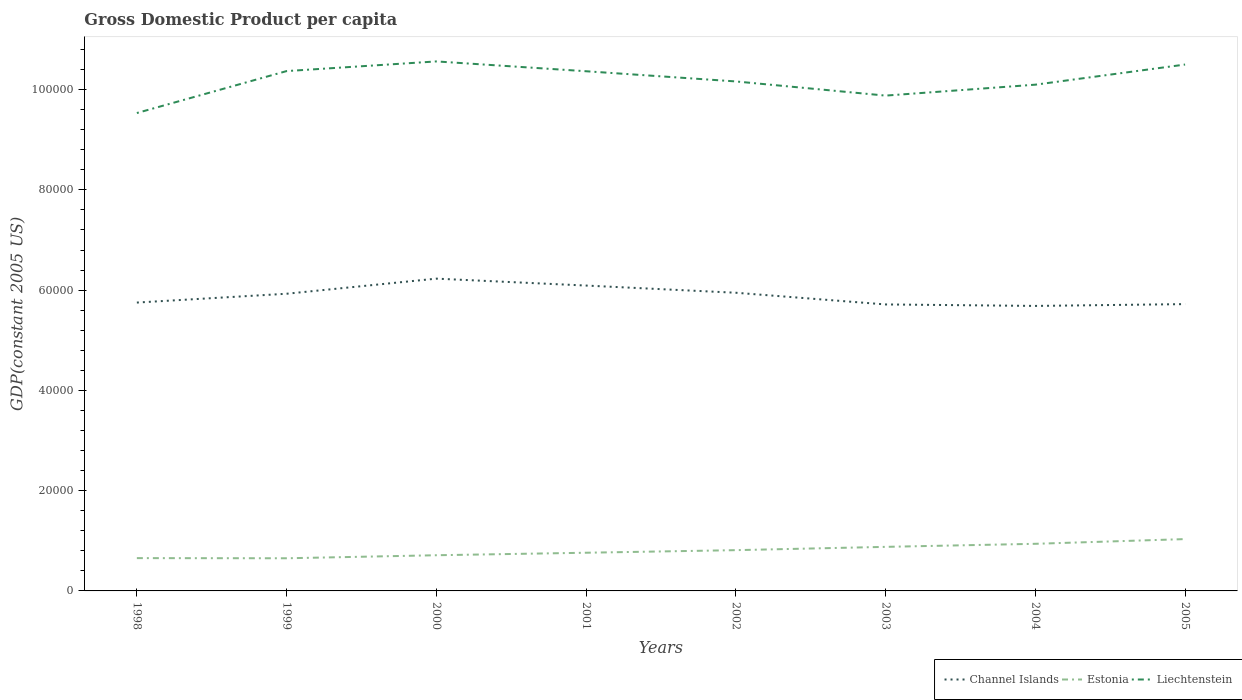How many different coloured lines are there?
Your answer should be compact. 3. Does the line corresponding to Liechtenstein intersect with the line corresponding to Estonia?
Provide a short and direct response. No. Across all years, what is the maximum GDP per capita in Liechtenstein?
Give a very brief answer. 9.53e+04. In which year was the GDP per capita in Liechtenstein maximum?
Give a very brief answer. 1998. What is the total GDP per capita in Estonia in the graph?
Make the answer very short. -1587.02. What is the difference between the highest and the second highest GDP per capita in Estonia?
Provide a short and direct response. 3824.29. What is the difference between the highest and the lowest GDP per capita in Channel Islands?
Make the answer very short. 4. How many lines are there?
Your response must be concise. 3. How many years are there in the graph?
Offer a terse response. 8. Are the values on the major ticks of Y-axis written in scientific E-notation?
Ensure brevity in your answer.  No. How many legend labels are there?
Your answer should be compact. 3. How are the legend labels stacked?
Make the answer very short. Horizontal. What is the title of the graph?
Your answer should be very brief. Gross Domestic Product per capita. Does "Korea (Democratic)" appear as one of the legend labels in the graph?
Give a very brief answer. No. What is the label or title of the X-axis?
Offer a very short reply. Years. What is the label or title of the Y-axis?
Provide a succinct answer. GDP(constant 2005 US). What is the GDP(constant 2005 US) in Channel Islands in 1998?
Give a very brief answer. 5.75e+04. What is the GDP(constant 2005 US) of Estonia in 1998?
Ensure brevity in your answer.  6544.06. What is the GDP(constant 2005 US) in Liechtenstein in 1998?
Give a very brief answer. 9.53e+04. What is the GDP(constant 2005 US) in Channel Islands in 1999?
Keep it short and to the point. 5.93e+04. What is the GDP(constant 2005 US) of Estonia in 1999?
Offer a terse response. 6514.02. What is the GDP(constant 2005 US) in Liechtenstein in 1999?
Ensure brevity in your answer.  1.04e+05. What is the GDP(constant 2005 US) of Channel Islands in 2000?
Make the answer very short. 6.23e+04. What is the GDP(constant 2005 US) in Estonia in 2000?
Make the answer very short. 7118.06. What is the GDP(constant 2005 US) in Liechtenstein in 2000?
Your answer should be compact. 1.06e+05. What is the GDP(constant 2005 US) of Channel Islands in 2001?
Offer a terse response. 6.09e+04. What is the GDP(constant 2005 US) of Estonia in 2001?
Your answer should be very brief. 7616.9. What is the GDP(constant 2005 US) in Liechtenstein in 2001?
Your response must be concise. 1.04e+05. What is the GDP(constant 2005 US) of Channel Islands in 2002?
Give a very brief answer. 5.95e+04. What is the GDP(constant 2005 US) of Estonia in 2002?
Make the answer very short. 8131.07. What is the GDP(constant 2005 US) in Liechtenstein in 2002?
Give a very brief answer. 1.02e+05. What is the GDP(constant 2005 US) in Channel Islands in 2003?
Give a very brief answer. 5.71e+04. What is the GDP(constant 2005 US) in Estonia in 2003?
Your response must be concise. 8789.08. What is the GDP(constant 2005 US) of Liechtenstein in 2003?
Provide a succinct answer. 9.88e+04. What is the GDP(constant 2005 US) of Channel Islands in 2004?
Your answer should be very brief. 5.68e+04. What is the GDP(constant 2005 US) in Estonia in 2004?
Your response must be concise. 9398.35. What is the GDP(constant 2005 US) in Liechtenstein in 2004?
Keep it short and to the point. 1.01e+05. What is the GDP(constant 2005 US) of Channel Islands in 2005?
Provide a succinct answer. 5.72e+04. What is the GDP(constant 2005 US) of Estonia in 2005?
Keep it short and to the point. 1.03e+04. What is the GDP(constant 2005 US) in Liechtenstein in 2005?
Provide a short and direct response. 1.05e+05. Across all years, what is the maximum GDP(constant 2005 US) in Channel Islands?
Your answer should be compact. 6.23e+04. Across all years, what is the maximum GDP(constant 2005 US) of Estonia?
Your response must be concise. 1.03e+04. Across all years, what is the maximum GDP(constant 2005 US) of Liechtenstein?
Provide a succinct answer. 1.06e+05. Across all years, what is the minimum GDP(constant 2005 US) in Channel Islands?
Keep it short and to the point. 5.68e+04. Across all years, what is the minimum GDP(constant 2005 US) in Estonia?
Keep it short and to the point. 6514.02. Across all years, what is the minimum GDP(constant 2005 US) of Liechtenstein?
Offer a very short reply. 9.53e+04. What is the total GDP(constant 2005 US) of Channel Islands in the graph?
Provide a succinct answer. 4.71e+05. What is the total GDP(constant 2005 US) of Estonia in the graph?
Offer a very short reply. 6.44e+04. What is the total GDP(constant 2005 US) of Liechtenstein in the graph?
Provide a short and direct response. 8.15e+05. What is the difference between the GDP(constant 2005 US) in Channel Islands in 1998 and that in 1999?
Make the answer very short. -1759.18. What is the difference between the GDP(constant 2005 US) in Estonia in 1998 and that in 1999?
Your answer should be very brief. 30.03. What is the difference between the GDP(constant 2005 US) in Liechtenstein in 1998 and that in 1999?
Give a very brief answer. -8366.76. What is the difference between the GDP(constant 2005 US) in Channel Islands in 1998 and that in 2000?
Make the answer very short. -4773.15. What is the difference between the GDP(constant 2005 US) in Estonia in 1998 and that in 2000?
Your answer should be very brief. -574. What is the difference between the GDP(constant 2005 US) in Liechtenstein in 1998 and that in 2000?
Keep it short and to the point. -1.03e+04. What is the difference between the GDP(constant 2005 US) in Channel Islands in 1998 and that in 2001?
Your answer should be compact. -3391.66. What is the difference between the GDP(constant 2005 US) in Estonia in 1998 and that in 2001?
Your response must be concise. -1072.84. What is the difference between the GDP(constant 2005 US) in Liechtenstein in 1998 and that in 2001?
Make the answer very short. -8333.14. What is the difference between the GDP(constant 2005 US) of Channel Islands in 1998 and that in 2002?
Offer a very short reply. -1957.56. What is the difference between the GDP(constant 2005 US) in Estonia in 1998 and that in 2002?
Offer a terse response. -1587.02. What is the difference between the GDP(constant 2005 US) of Liechtenstein in 1998 and that in 2002?
Offer a terse response. -6300.59. What is the difference between the GDP(constant 2005 US) of Channel Islands in 1998 and that in 2003?
Offer a very short reply. 374.48. What is the difference between the GDP(constant 2005 US) of Estonia in 1998 and that in 2003?
Offer a terse response. -2245.03. What is the difference between the GDP(constant 2005 US) of Liechtenstein in 1998 and that in 2003?
Ensure brevity in your answer.  -3474.17. What is the difference between the GDP(constant 2005 US) in Channel Islands in 1998 and that in 2004?
Your answer should be very brief. 671.13. What is the difference between the GDP(constant 2005 US) of Estonia in 1998 and that in 2004?
Your answer should be compact. -2854.29. What is the difference between the GDP(constant 2005 US) in Liechtenstein in 1998 and that in 2004?
Provide a short and direct response. -5655.22. What is the difference between the GDP(constant 2005 US) of Channel Islands in 1998 and that in 2005?
Offer a terse response. 309.23. What is the difference between the GDP(constant 2005 US) in Estonia in 1998 and that in 2005?
Your answer should be compact. -3794.26. What is the difference between the GDP(constant 2005 US) of Liechtenstein in 1998 and that in 2005?
Your response must be concise. -9671.07. What is the difference between the GDP(constant 2005 US) of Channel Islands in 1999 and that in 2000?
Offer a terse response. -3013.96. What is the difference between the GDP(constant 2005 US) of Estonia in 1999 and that in 2000?
Your answer should be very brief. -604.03. What is the difference between the GDP(constant 2005 US) in Liechtenstein in 1999 and that in 2000?
Provide a succinct answer. -1927.3. What is the difference between the GDP(constant 2005 US) in Channel Islands in 1999 and that in 2001?
Give a very brief answer. -1632.48. What is the difference between the GDP(constant 2005 US) in Estonia in 1999 and that in 2001?
Your answer should be very brief. -1102.88. What is the difference between the GDP(constant 2005 US) in Liechtenstein in 1999 and that in 2001?
Offer a very short reply. 33.62. What is the difference between the GDP(constant 2005 US) of Channel Islands in 1999 and that in 2002?
Offer a very short reply. -198.38. What is the difference between the GDP(constant 2005 US) in Estonia in 1999 and that in 2002?
Provide a succinct answer. -1617.05. What is the difference between the GDP(constant 2005 US) of Liechtenstein in 1999 and that in 2002?
Your answer should be compact. 2066.18. What is the difference between the GDP(constant 2005 US) of Channel Islands in 1999 and that in 2003?
Keep it short and to the point. 2133.67. What is the difference between the GDP(constant 2005 US) in Estonia in 1999 and that in 2003?
Offer a terse response. -2275.06. What is the difference between the GDP(constant 2005 US) in Liechtenstein in 1999 and that in 2003?
Your answer should be very brief. 4892.59. What is the difference between the GDP(constant 2005 US) in Channel Islands in 1999 and that in 2004?
Keep it short and to the point. 2430.31. What is the difference between the GDP(constant 2005 US) of Estonia in 1999 and that in 2004?
Offer a very short reply. -2884.33. What is the difference between the GDP(constant 2005 US) of Liechtenstein in 1999 and that in 2004?
Give a very brief answer. 2711.54. What is the difference between the GDP(constant 2005 US) of Channel Islands in 1999 and that in 2005?
Ensure brevity in your answer.  2068.42. What is the difference between the GDP(constant 2005 US) in Estonia in 1999 and that in 2005?
Provide a succinct answer. -3824.29. What is the difference between the GDP(constant 2005 US) in Liechtenstein in 1999 and that in 2005?
Provide a succinct answer. -1304.31. What is the difference between the GDP(constant 2005 US) in Channel Islands in 2000 and that in 2001?
Your answer should be compact. 1381.48. What is the difference between the GDP(constant 2005 US) in Estonia in 2000 and that in 2001?
Offer a terse response. -498.84. What is the difference between the GDP(constant 2005 US) in Liechtenstein in 2000 and that in 2001?
Offer a very short reply. 1960.92. What is the difference between the GDP(constant 2005 US) in Channel Islands in 2000 and that in 2002?
Your response must be concise. 2815.59. What is the difference between the GDP(constant 2005 US) in Estonia in 2000 and that in 2002?
Provide a short and direct response. -1013.02. What is the difference between the GDP(constant 2005 US) of Liechtenstein in 2000 and that in 2002?
Provide a succinct answer. 3993.48. What is the difference between the GDP(constant 2005 US) in Channel Islands in 2000 and that in 2003?
Provide a succinct answer. 5147.63. What is the difference between the GDP(constant 2005 US) in Estonia in 2000 and that in 2003?
Give a very brief answer. -1671.03. What is the difference between the GDP(constant 2005 US) of Liechtenstein in 2000 and that in 2003?
Your answer should be compact. 6819.89. What is the difference between the GDP(constant 2005 US) in Channel Islands in 2000 and that in 2004?
Your answer should be very brief. 5444.28. What is the difference between the GDP(constant 2005 US) in Estonia in 2000 and that in 2004?
Offer a terse response. -2280.29. What is the difference between the GDP(constant 2005 US) in Liechtenstein in 2000 and that in 2004?
Your response must be concise. 4638.84. What is the difference between the GDP(constant 2005 US) in Channel Islands in 2000 and that in 2005?
Your response must be concise. 5082.38. What is the difference between the GDP(constant 2005 US) in Estonia in 2000 and that in 2005?
Provide a short and direct response. -3220.26. What is the difference between the GDP(constant 2005 US) in Liechtenstein in 2000 and that in 2005?
Your answer should be very brief. 623. What is the difference between the GDP(constant 2005 US) of Channel Islands in 2001 and that in 2002?
Offer a very short reply. 1434.1. What is the difference between the GDP(constant 2005 US) in Estonia in 2001 and that in 2002?
Your answer should be very brief. -514.18. What is the difference between the GDP(constant 2005 US) of Liechtenstein in 2001 and that in 2002?
Provide a succinct answer. 2032.56. What is the difference between the GDP(constant 2005 US) in Channel Islands in 2001 and that in 2003?
Provide a succinct answer. 3766.15. What is the difference between the GDP(constant 2005 US) of Estonia in 2001 and that in 2003?
Provide a succinct answer. -1172.18. What is the difference between the GDP(constant 2005 US) in Liechtenstein in 2001 and that in 2003?
Offer a terse response. 4858.97. What is the difference between the GDP(constant 2005 US) in Channel Islands in 2001 and that in 2004?
Your response must be concise. 4062.79. What is the difference between the GDP(constant 2005 US) of Estonia in 2001 and that in 2004?
Offer a terse response. -1781.45. What is the difference between the GDP(constant 2005 US) in Liechtenstein in 2001 and that in 2004?
Provide a succinct answer. 2677.92. What is the difference between the GDP(constant 2005 US) of Channel Islands in 2001 and that in 2005?
Keep it short and to the point. 3700.9. What is the difference between the GDP(constant 2005 US) in Estonia in 2001 and that in 2005?
Make the answer very short. -2721.42. What is the difference between the GDP(constant 2005 US) of Liechtenstein in 2001 and that in 2005?
Provide a short and direct response. -1337.93. What is the difference between the GDP(constant 2005 US) of Channel Islands in 2002 and that in 2003?
Your answer should be compact. 2332.04. What is the difference between the GDP(constant 2005 US) in Estonia in 2002 and that in 2003?
Offer a terse response. -658.01. What is the difference between the GDP(constant 2005 US) in Liechtenstein in 2002 and that in 2003?
Provide a short and direct response. 2826.41. What is the difference between the GDP(constant 2005 US) in Channel Islands in 2002 and that in 2004?
Keep it short and to the point. 2628.69. What is the difference between the GDP(constant 2005 US) of Estonia in 2002 and that in 2004?
Provide a succinct answer. -1267.27. What is the difference between the GDP(constant 2005 US) of Liechtenstein in 2002 and that in 2004?
Offer a terse response. 645.36. What is the difference between the GDP(constant 2005 US) of Channel Islands in 2002 and that in 2005?
Your response must be concise. 2266.79. What is the difference between the GDP(constant 2005 US) in Estonia in 2002 and that in 2005?
Give a very brief answer. -2207.24. What is the difference between the GDP(constant 2005 US) in Liechtenstein in 2002 and that in 2005?
Offer a terse response. -3370.48. What is the difference between the GDP(constant 2005 US) in Channel Islands in 2003 and that in 2004?
Your response must be concise. 296.65. What is the difference between the GDP(constant 2005 US) of Estonia in 2003 and that in 2004?
Offer a very short reply. -609.27. What is the difference between the GDP(constant 2005 US) of Liechtenstein in 2003 and that in 2004?
Your answer should be compact. -2181.05. What is the difference between the GDP(constant 2005 US) in Channel Islands in 2003 and that in 2005?
Your answer should be compact. -65.25. What is the difference between the GDP(constant 2005 US) of Estonia in 2003 and that in 2005?
Make the answer very short. -1549.24. What is the difference between the GDP(constant 2005 US) of Liechtenstein in 2003 and that in 2005?
Give a very brief answer. -6196.9. What is the difference between the GDP(constant 2005 US) of Channel Islands in 2004 and that in 2005?
Provide a succinct answer. -361.9. What is the difference between the GDP(constant 2005 US) of Estonia in 2004 and that in 2005?
Offer a terse response. -939.97. What is the difference between the GDP(constant 2005 US) of Liechtenstein in 2004 and that in 2005?
Offer a very short reply. -4015.84. What is the difference between the GDP(constant 2005 US) in Channel Islands in 1998 and the GDP(constant 2005 US) in Estonia in 1999?
Your response must be concise. 5.10e+04. What is the difference between the GDP(constant 2005 US) in Channel Islands in 1998 and the GDP(constant 2005 US) in Liechtenstein in 1999?
Your response must be concise. -4.62e+04. What is the difference between the GDP(constant 2005 US) of Estonia in 1998 and the GDP(constant 2005 US) of Liechtenstein in 1999?
Offer a terse response. -9.71e+04. What is the difference between the GDP(constant 2005 US) of Channel Islands in 1998 and the GDP(constant 2005 US) of Estonia in 2000?
Provide a short and direct response. 5.04e+04. What is the difference between the GDP(constant 2005 US) in Channel Islands in 1998 and the GDP(constant 2005 US) in Liechtenstein in 2000?
Keep it short and to the point. -4.81e+04. What is the difference between the GDP(constant 2005 US) in Estonia in 1998 and the GDP(constant 2005 US) in Liechtenstein in 2000?
Give a very brief answer. -9.91e+04. What is the difference between the GDP(constant 2005 US) of Channel Islands in 1998 and the GDP(constant 2005 US) of Estonia in 2001?
Give a very brief answer. 4.99e+04. What is the difference between the GDP(constant 2005 US) in Channel Islands in 1998 and the GDP(constant 2005 US) in Liechtenstein in 2001?
Keep it short and to the point. -4.61e+04. What is the difference between the GDP(constant 2005 US) of Estonia in 1998 and the GDP(constant 2005 US) of Liechtenstein in 2001?
Offer a terse response. -9.71e+04. What is the difference between the GDP(constant 2005 US) in Channel Islands in 1998 and the GDP(constant 2005 US) in Estonia in 2002?
Make the answer very short. 4.94e+04. What is the difference between the GDP(constant 2005 US) of Channel Islands in 1998 and the GDP(constant 2005 US) of Liechtenstein in 2002?
Your answer should be very brief. -4.41e+04. What is the difference between the GDP(constant 2005 US) of Estonia in 1998 and the GDP(constant 2005 US) of Liechtenstein in 2002?
Keep it short and to the point. -9.51e+04. What is the difference between the GDP(constant 2005 US) of Channel Islands in 1998 and the GDP(constant 2005 US) of Estonia in 2003?
Provide a succinct answer. 4.87e+04. What is the difference between the GDP(constant 2005 US) of Channel Islands in 1998 and the GDP(constant 2005 US) of Liechtenstein in 2003?
Provide a short and direct response. -4.13e+04. What is the difference between the GDP(constant 2005 US) in Estonia in 1998 and the GDP(constant 2005 US) in Liechtenstein in 2003?
Your answer should be very brief. -9.23e+04. What is the difference between the GDP(constant 2005 US) in Channel Islands in 1998 and the GDP(constant 2005 US) in Estonia in 2004?
Provide a succinct answer. 4.81e+04. What is the difference between the GDP(constant 2005 US) in Channel Islands in 1998 and the GDP(constant 2005 US) in Liechtenstein in 2004?
Ensure brevity in your answer.  -4.35e+04. What is the difference between the GDP(constant 2005 US) in Estonia in 1998 and the GDP(constant 2005 US) in Liechtenstein in 2004?
Provide a short and direct response. -9.44e+04. What is the difference between the GDP(constant 2005 US) in Channel Islands in 1998 and the GDP(constant 2005 US) in Estonia in 2005?
Ensure brevity in your answer.  4.72e+04. What is the difference between the GDP(constant 2005 US) of Channel Islands in 1998 and the GDP(constant 2005 US) of Liechtenstein in 2005?
Your response must be concise. -4.75e+04. What is the difference between the GDP(constant 2005 US) of Estonia in 1998 and the GDP(constant 2005 US) of Liechtenstein in 2005?
Your answer should be compact. -9.85e+04. What is the difference between the GDP(constant 2005 US) of Channel Islands in 1999 and the GDP(constant 2005 US) of Estonia in 2000?
Make the answer very short. 5.22e+04. What is the difference between the GDP(constant 2005 US) in Channel Islands in 1999 and the GDP(constant 2005 US) in Liechtenstein in 2000?
Provide a short and direct response. -4.63e+04. What is the difference between the GDP(constant 2005 US) in Estonia in 1999 and the GDP(constant 2005 US) in Liechtenstein in 2000?
Give a very brief answer. -9.91e+04. What is the difference between the GDP(constant 2005 US) in Channel Islands in 1999 and the GDP(constant 2005 US) in Estonia in 2001?
Offer a very short reply. 5.17e+04. What is the difference between the GDP(constant 2005 US) of Channel Islands in 1999 and the GDP(constant 2005 US) of Liechtenstein in 2001?
Provide a succinct answer. -4.44e+04. What is the difference between the GDP(constant 2005 US) of Estonia in 1999 and the GDP(constant 2005 US) of Liechtenstein in 2001?
Provide a succinct answer. -9.71e+04. What is the difference between the GDP(constant 2005 US) in Channel Islands in 1999 and the GDP(constant 2005 US) in Estonia in 2002?
Provide a short and direct response. 5.11e+04. What is the difference between the GDP(constant 2005 US) of Channel Islands in 1999 and the GDP(constant 2005 US) of Liechtenstein in 2002?
Provide a short and direct response. -4.23e+04. What is the difference between the GDP(constant 2005 US) in Estonia in 1999 and the GDP(constant 2005 US) in Liechtenstein in 2002?
Your response must be concise. -9.51e+04. What is the difference between the GDP(constant 2005 US) in Channel Islands in 1999 and the GDP(constant 2005 US) in Estonia in 2003?
Provide a short and direct response. 5.05e+04. What is the difference between the GDP(constant 2005 US) in Channel Islands in 1999 and the GDP(constant 2005 US) in Liechtenstein in 2003?
Your response must be concise. -3.95e+04. What is the difference between the GDP(constant 2005 US) of Estonia in 1999 and the GDP(constant 2005 US) of Liechtenstein in 2003?
Make the answer very short. -9.23e+04. What is the difference between the GDP(constant 2005 US) of Channel Islands in 1999 and the GDP(constant 2005 US) of Estonia in 2004?
Your answer should be very brief. 4.99e+04. What is the difference between the GDP(constant 2005 US) of Channel Islands in 1999 and the GDP(constant 2005 US) of Liechtenstein in 2004?
Offer a very short reply. -4.17e+04. What is the difference between the GDP(constant 2005 US) of Estonia in 1999 and the GDP(constant 2005 US) of Liechtenstein in 2004?
Make the answer very short. -9.45e+04. What is the difference between the GDP(constant 2005 US) in Channel Islands in 1999 and the GDP(constant 2005 US) in Estonia in 2005?
Provide a succinct answer. 4.89e+04. What is the difference between the GDP(constant 2005 US) in Channel Islands in 1999 and the GDP(constant 2005 US) in Liechtenstein in 2005?
Offer a very short reply. -4.57e+04. What is the difference between the GDP(constant 2005 US) of Estonia in 1999 and the GDP(constant 2005 US) of Liechtenstein in 2005?
Your answer should be very brief. -9.85e+04. What is the difference between the GDP(constant 2005 US) of Channel Islands in 2000 and the GDP(constant 2005 US) of Estonia in 2001?
Offer a terse response. 5.47e+04. What is the difference between the GDP(constant 2005 US) of Channel Islands in 2000 and the GDP(constant 2005 US) of Liechtenstein in 2001?
Offer a very short reply. -4.14e+04. What is the difference between the GDP(constant 2005 US) of Estonia in 2000 and the GDP(constant 2005 US) of Liechtenstein in 2001?
Your answer should be compact. -9.65e+04. What is the difference between the GDP(constant 2005 US) in Channel Islands in 2000 and the GDP(constant 2005 US) in Estonia in 2002?
Provide a short and direct response. 5.42e+04. What is the difference between the GDP(constant 2005 US) of Channel Islands in 2000 and the GDP(constant 2005 US) of Liechtenstein in 2002?
Give a very brief answer. -3.93e+04. What is the difference between the GDP(constant 2005 US) of Estonia in 2000 and the GDP(constant 2005 US) of Liechtenstein in 2002?
Keep it short and to the point. -9.45e+04. What is the difference between the GDP(constant 2005 US) of Channel Islands in 2000 and the GDP(constant 2005 US) of Estonia in 2003?
Offer a terse response. 5.35e+04. What is the difference between the GDP(constant 2005 US) in Channel Islands in 2000 and the GDP(constant 2005 US) in Liechtenstein in 2003?
Your response must be concise. -3.65e+04. What is the difference between the GDP(constant 2005 US) of Estonia in 2000 and the GDP(constant 2005 US) of Liechtenstein in 2003?
Provide a short and direct response. -9.17e+04. What is the difference between the GDP(constant 2005 US) in Channel Islands in 2000 and the GDP(constant 2005 US) in Estonia in 2004?
Your answer should be very brief. 5.29e+04. What is the difference between the GDP(constant 2005 US) in Channel Islands in 2000 and the GDP(constant 2005 US) in Liechtenstein in 2004?
Make the answer very short. -3.87e+04. What is the difference between the GDP(constant 2005 US) of Estonia in 2000 and the GDP(constant 2005 US) of Liechtenstein in 2004?
Your answer should be compact. -9.39e+04. What is the difference between the GDP(constant 2005 US) in Channel Islands in 2000 and the GDP(constant 2005 US) in Estonia in 2005?
Provide a succinct answer. 5.20e+04. What is the difference between the GDP(constant 2005 US) in Channel Islands in 2000 and the GDP(constant 2005 US) in Liechtenstein in 2005?
Offer a very short reply. -4.27e+04. What is the difference between the GDP(constant 2005 US) of Estonia in 2000 and the GDP(constant 2005 US) of Liechtenstein in 2005?
Offer a terse response. -9.79e+04. What is the difference between the GDP(constant 2005 US) in Channel Islands in 2001 and the GDP(constant 2005 US) in Estonia in 2002?
Offer a terse response. 5.28e+04. What is the difference between the GDP(constant 2005 US) in Channel Islands in 2001 and the GDP(constant 2005 US) in Liechtenstein in 2002?
Your response must be concise. -4.07e+04. What is the difference between the GDP(constant 2005 US) of Estonia in 2001 and the GDP(constant 2005 US) of Liechtenstein in 2002?
Give a very brief answer. -9.40e+04. What is the difference between the GDP(constant 2005 US) of Channel Islands in 2001 and the GDP(constant 2005 US) of Estonia in 2003?
Provide a short and direct response. 5.21e+04. What is the difference between the GDP(constant 2005 US) of Channel Islands in 2001 and the GDP(constant 2005 US) of Liechtenstein in 2003?
Ensure brevity in your answer.  -3.79e+04. What is the difference between the GDP(constant 2005 US) in Estonia in 2001 and the GDP(constant 2005 US) in Liechtenstein in 2003?
Offer a terse response. -9.12e+04. What is the difference between the GDP(constant 2005 US) in Channel Islands in 2001 and the GDP(constant 2005 US) in Estonia in 2004?
Give a very brief answer. 5.15e+04. What is the difference between the GDP(constant 2005 US) in Channel Islands in 2001 and the GDP(constant 2005 US) in Liechtenstein in 2004?
Offer a very short reply. -4.01e+04. What is the difference between the GDP(constant 2005 US) of Estonia in 2001 and the GDP(constant 2005 US) of Liechtenstein in 2004?
Provide a short and direct response. -9.34e+04. What is the difference between the GDP(constant 2005 US) of Channel Islands in 2001 and the GDP(constant 2005 US) of Estonia in 2005?
Your answer should be compact. 5.06e+04. What is the difference between the GDP(constant 2005 US) in Channel Islands in 2001 and the GDP(constant 2005 US) in Liechtenstein in 2005?
Your answer should be very brief. -4.41e+04. What is the difference between the GDP(constant 2005 US) in Estonia in 2001 and the GDP(constant 2005 US) in Liechtenstein in 2005?
Ensure brevity in your answer.  -9.74e+04. What is the difference between the GDP(constant 2005 US) in Channel Islands in 2002 and the GDP(constant 2005 US) in Estonia in 2003?
Your response must be concise. 5.07e+04. What is the difference between the GDP(constant 2005 US) of Channel Islands in 2002 and the GDP(constant 2005 US) of Liechtenstein in 2003?
Your answer should be very brief. -3.93e+04. What is the difference between the GDP(constant 2005 US) in Estonia in 2002 and the GDP(constant 2005 US) in Liechtenstein in 2003?
Your response must be concise. -9.07e+04. What is the difference between the GDP(constant 2005 US) in Channel Islands in 2002 and the GDP(constant 2005 US) in Estonia in 2004?
Keep it short and to the point. 5.01e+04. What is the difference between the GDP(constant 2005 US) of Channel Islands in 2002 and the GDP(constant 2005 US) of Liechtenstein in 2004?
Offer a very short reply. -4.15e+04. What is the difference between the GDP(constant 2005 US) in Estonia in 2002 and the GDP(constant 2005 US) in Liechtenstein in 2004?
Make the answer very short. -9.28e+04. What is the difference between the GDP(constant 2005 US) in Channel Islands in 2002 and the GDP(constant 2005 US) in Estonia in 2005?
Keep it short and to the point. 4.91e+04. What is the difference between the GDP(constant 2005 US) of Channel Islands in 2002 and the GDP(constant 2005 US) of Liechtenstein in 2005?
Keep it short and to the point. -4.55e+04. What is the difference between the GDP(constant 2005 US) in Estonia in 2002 and the GDP(constant 2005 US) in Liechtenstein in 2005?
Offer a terse response. -9.69e+04. What is the difference between the GDP(constant 2005 US) of Channel Islands in 2003 and the GDP(constant 2005 US) of Estonia in 2004?
Keep it short and to the point. 4.77e+04. What is the difference between the GDP(constant 2005 US) of Channel Islands in 2003 and the GDP(constant 2005 US) of Liechtenstein in 2004?
Make the answer very short. -4.38e+04. What is the difference between the GDP(constant 2005 US) of Estonia in 2003 and the GDP(constant 2005 US) of Liechtenstein in 2004?
Provide a succinct answer. -9.22e+04. What is the difference between the GDP(constant 2005 US) of Channel Islands in 2003 and the GDP(constant 2005 US) of Estonia in 2005?
Ensure brevity in your answer.  4.68e+04. What is the difference between the GDP(constant 2005 US) of Channel Islands in 2003 and the GDP(constant 2005 US) of Liechtenstein in 2005?
Make the answer very short. -4.79e+04. What is the difference between the GDP(constant 2005 US) of Estonia in 2003 and the GDP(constant 2005 US) of Liechtenstein in 2005?
Provide a succinct answer. -9.62e+04. What is the difference between the GDP(constant 2005 US) of Channel Islands in 2004 and the GDP(constant 2005 US) of Estonia in 2005?
Your response must be concise. 4.65e+04. What is the difference between the GDP(constant 2005 US) of Channel Islands in 2004 and the GDP(constant 2005 US) of Liechtenstein in 2005?
Provide a succinct answer. -4.81e+04. What is the difference between the GDP(constant 2005 US) in Estonia in 2004 and the GDP(constant 2005 US) in Liechtenstein in 2005?
Make the answer very short. -9.56e+04. What is the average GDP(constant 2005 US) in Channel Islands per year?
Offer a very short reply. 5.88e+04. What is the average GDP(constant 2005 US) in Estonia per year?
Your response must be concise. 8056.23. What is the average GDP(constant 2005 US) of Liechtenstein per year?
Provide a short and direct response. 1.02e+05. In the year 1998, what is the difference between the GDP(constant 2005 US) of Channel Islands and GDP(constant 2005 US) of Estonia?
Give a very brief answer. 5.10e+04. In the year 1998, what is the difference between the GDP(constant 2005 US) in Channel Islands and GDP(constant 2005 US) in Liechtenstein?
Give a very brief answer. -3.78e+04. In the year 1998, what is the difference between the GDP(constant 2005 US) in Estonia and GDP(constant 2005 US) in Liechtenstein?
Your answer should be very brief. -8.88e+04. In the year 1999, what is the difference between the GDP(constant 2005 US) of Channel Islands and GDP(constant 2005 US) of Estonia?
Ensure brevity in your answer.  5.28e+04. In the year 1999, what is the difference between the GDP(constant 2005 US) in Channel Islands and GDP(constant 2005 US) in Liechtenstein?
Your response must be concise. -4.44e+04. In the year 1999, what is the difference between the GDP(constant 2005 US) in Estonia and GDP(constant 2005 US) in Liechtenstein?
Provide a short and direct response. -9.72e+04. In the year 2000, what is the difference between the GDP(constant 2005 US) of Channel Islands and GDP(constant 2005 US) of Estonia?
Offer a terse response. 5.52e+04. In the year 2000, what is the difference between the GDP(constant 2005 US) in Channel Islands and GDP(constant 2005 US) in Liechtenstein?
Your answer should be compact. -4.33e+04. In the year 2000, what is the difference between the GDP(constant 2005 US) in Estonia and GDP(constant 2005 US) in Liechtenstein?
Provide a short and direct response. -9.85e+04. In the year 2001, what is the difference between the GDP(constant 2005 US) in Channel Islands and GDP(constant 2005 US) in Estonia?
Make the answer very short. 5.33e+04. In the year 2001, what is the difference between the GDP(constant 2005 US) in Channel Islands and GDP(constant 2005 US) in Liechtenstein?
Offer a terse response. -4.27e+04. In the year 2001, what is the difference between the GDP(constant 2005 US) in Estonia and GDP(constant 2005 US) in Liechtenstein?
Your answer should be compact. -9.60e+04. In the year 2002, what is the difference between the GDP(constant 2005 US) in Channel Islands and GDP(constant 2005 US) in Estonia?
Offer a terse response. 5.13e+04. In the year 2002, what is the difference between the GDP(constant 2005 US) of Channel Islands and GDP(constant 2005 US) of Liechtenstein?
Keep it short and to the point. -4.21e+04. In the year 2002, what is the difference between the GDP(constant 2005 US) in Estonia and GDP(constant 2005 US) in Liechtenstein?
Your answer should be compact. -9.35e+04. In the year 2003, what is the difference between the GDP(constant 2005 US) in Channel Islands and GDP(constant 2005 US) in Estonia?
Give a very brief answer. 4.84e+04. In the year 2003, what is the difference between the GDP(constant 2005 US) of Channel Islands and GDP(constant 2005 US) of Liechtenstein?
Provide a short and direct response. -4.17e+04. In the year 2003, what is the difference between the GDP(constant 2005 US) of Estonia and GDP(constant 2005 US) of Liechtenstein?
Your response must be concise. -9.00e+04. In the year 2004, what is the difference between the GDP(constant 2005 US) of Channel Islands and GDP(constant 2005 US) of Estonia?
Provide a short and direct response. 4.74e+04. In the year 2004, what is the difference between the GDP(constant 2005 US) of Channel Islands and GDP(constant 2005 US) of Liechtenstein?
Keep it short and to the point. -4.41e+04. In the year 2004, what is the difference between the GDP(constant 2005 US) in Estonia and GDP(constant 2005 US) in Liechtenstein?
Your answer should be very brief. -9.16e+04. In the year 2005, what is the difference between the GDP(constant 2005 US) in Channel Islands and GDP(constant 2005 US) in Estonia?
Your response must be concise. 4.69e+04. In the year 2005, what is the difference between the GDP(constant 2005 US) in Channel Islands and GDP(constant 2005 US) in Liechtenstein?
Your response must be concise. -4.78e+04. In the year 2005, what is the difference between the GDP(constant 2005 US) in Estonia and GDP(constant 2005 US) in Liechtenstein?
Offer a very short reply. -9.47e+04. What is the ratio of the GDP(constant 2005 US) in Channel Islands in 1998 to that in 1999?
Offer a terse response. 0.97. What is the ratio of the GDP(constant 2005 US) of Liechtenstein in 1998 to that in 1999?
Your answer should be compact. 0.92. What is the ratio of the GDP(constant 2005 US) in Channel Islands in 1998 to that in 2000?
Keep it short and to the point. 0.92. What is the ratio of the GDP(constant 2005 US) in Estonia in 1998 to that in 2000?
Provide a short and direct response. 0.92. What is the ratio of the GDP(constant 2005 US) of Liechtenstein in 1998 to that in 2000?
Give a very brief answer. 0.9. What is the ratio of the GDP(constant 2005 US) in Channel Islands in 1998 to that in 2001?
Make the answer very short. 0.94. What is the ratio of the GDP(constant 2005 US) of Estonia in 1998 to that in 2001?
Keep it short and to the point. 0.86. What is the ratio of the GDP(constant 2005 US) of Liechtenstein in 1998 to that in 2001?
Make the answer very short. 0.92. What is the ratio of the GDP(constant 2005 US) in Channel Islands in 1998 to that in 2002?
Offer a terse response. 0.97. What is the ratio of the GDP(constant 2005 US) in Estonia in 1998 to that in 2002?
Your answer should be compact. 0.8. What is the ratio of the GDP(constant 2005 US) of Liechtenstein in 1998 to that in 2002?
Your answer should be compact. 0.94. What is the ratio of the GDP(constant 2005 US) in Channel Islands in 1998 to that in 2003?
Ensure brevity in your answer.  1.01. What is the ratio of the GDP(constant 2005 US) in Estonia in 1998 to that in 2003?
Keep it short and to the point. 0.74. What is the ratio of the GDP(constant 2005 US) in Liechtenstein in 1998 to that in 2003?
Ensure brevity in your answer.  0.96. What is the ratio of the GDP(constant 2005 US) of Channel Islands in 1998 to that in 2004?
Provide a short and direct response. 1.01. What is the ratio of the GDP(constant 2005 US) in Estonia in 1998 to that in 2004?
Provide a short and direct response. 0.7. What is the ratio of the GDP(constant 2005 US) of Liechtenstein in 1998 to that in 2004?
Make the answer very short. 0.94. What is the ratio of the GDP(constant 2005 US) of Channel Islands in 1998 to that in 2005?
Provide a succinct answer. 1.01. What is the ratio of the GDP(constant 2005 US) of Estonia in 1998 to that in 2005?
Keep it short and to the point. 0.63. What is the ratio of the GDP(constant 2005 US) in Liechtenstein in 1998 to that in 2005?
Your response must be concise. 0.91. What is the ratio of the GDP(constant 2005 US) in Channel Islands in 1999 to that in 2000?
Your answer should be compact. 0.95. What is the ratio of the GDP(constant 2005 US) in Estonia in 1999 to that in 2000?
Offer a very short reply. 0.92. What is the ratio of the GDP(constant 2005 US) in Liechtenstein in 1999 to that in 2000?
Your response must be concise. 0.98. What is the ratio of the GDP(constant 2005 US) in Channel Islands in 1999 to that in 2001?
Offer a very short reply. 0.97. What is the ratio of the GDP(constant 2005 US) in Estonia in 1999 to that in 2001?
Provide a succinct answer. 0.86. What is the ratio of the GDP(constant 2005 US) in Channel Islands in 1999 to that in 2002?
Your response must be concise. 1. What is the ratio of the GDP(constant 2005 US) in Estonia in 1999 to that in 2002?
Ensure brevity in your answer.  0.8. What is the ratio of the GDP(constant 2005 US) of Liechtenstein in 1999 to that in 2002?
Provide a succinct answer. 1.02. What is the ratio of the GDP(constant 2005 US) of Channel Islands in 1999 to that in 2003?
Provide a succinct answer. 1.04. What is the ratio of the GDP(constant 2005 US) of Estonia in 1999 to that in 2003?
Your answer should be very brief. 0.74. What is the ratio of the GDP(constant 2005 US) of Liechtenstein in 1999 to that in 2003?
Offer a very short reply. 1.05. What is the ratio of the GDP(constant 2005 US) of Channel Islands in 1999 to that in 2004?
Keep it short and to the point. 1.04. What is the ratio of the GDP(constant 2005 US) of Estonia in 1999 to that in 2004?
Ensure brevity in your answer.  0.69. What is the ratio of the GDP(constant 2005 US) in Liechtenstein in 1999 to that in 2004?
Your answer should be very brief. 1.03. What is the ratio of the GDP(constant 2005 US) of Channel Islands in 1999 to that in 2005?
Offer a very short reply. 1.04. What is the ratio of the GDP(constant 2005 US) in Estonia in 1999 to that in 2005?
Provide a short and direct response. 0.63. What is the ratio of the GDP(constant 2005 US) in Liechtenstein in 1999 to that in 2005?
Offer a terse response. 0.99. What is the ratio of the GDP(constant 2005 US) of Channel Islands in 2000 to that in 2001?
Ensure brevity in your answer.  1.02. What is the ratio of the GDP(constant 2005 US) of Estonia in 2000 to that in 2001?
Provide a short and direct response. 0.93. What is the ratio of the GDP(constant 2005 US) in Liechtenstein in 2000 to that in 2001?
Give a very brief answer. 1.02. What is the ratio of the GDP(constant 2005 US) in Channel Islands in 2000 to that in 2002?
Your response must be concise. 1.05. What is the ratio of the GDP(constant 2005 US) in Estonia in 2000 to that in 2002?
Your response must be concise. 0.88. What is the ratio of the GDP(constant 2005 US) of Liechtenstein in 2000 to that in 2002?
Offer a terse response. 1.04. What is the ratio of the GDP(constant 2005 US) in Channel Islands in 2000 to that in 2003?
Keep it short and to the point. 1.09. What is the ratio of the GDP(constant 2005 US) of Estonia in 2000 to that in 2003?
Make the answer very short. 0.81. What is the ratio of the GDP(constant 2005 US) of Liechtenstein in 2000 to that in 2003?
Provide a succinct answer. 1.07. What is the ratio of the GDP(constant 2005 US) of Channel Islands in 2000 to that in 2004?
Your answer should be compact. 1.1. What is the ratio of the GDP(constant 2005 US) in Estonia in 2000 to that in 2004?
Make the answer very short. 0.76. What is the ratio of the GDP(constant 2005 US) in Liechtenstein in 2000 to that in 2004?
Your answer should be compact. 1.05. What is the ratio of the GDP(constant 2005 US) of Channel Islands in 2000 to that in 2005?
Your answer should be compact. 1.09. What is the ratio of the GDP(constant 2005 US) in Estonia in 2000 to that in 2005?
Offer a very short reply. 0.69. What is the ratio of the GDP(constant 2005 US) in Liechtenstein in 2000 to that in 2005?
Ensure brevity in your answer.  1.01. What is the ratio of the GDP(constant 2005 US) in Channel Islands in 2001 to that in 2002?
Your response must be concise. 1.02. What is the ratio of the GDP(constant 2005 US) in Estonia in 2001 to that in 2002?
Keep it short and to the point. 0.94. What is the ratio of the GDP(constant 2005 US) of Channel Islands in 2001 to that in 2003?
Ensure brevity in your answer.  1.07. What is the ratio of the GDP(constant 2005 US) in Estonia in 2001 to that in 2003?
Ensure brevity in your answer.  0.87. What is the ratio of the GDP(constant 2005 US) in Liechtenstein in 2001 to that in 2003?
Offer a very short reply. 1.05. What is the ratio of the GDP(constant 2005 US) of Channel Islands in 2001 to that in 2004?
Provide a succinct answer. 1.07. What is the ratio of the GDP(constant 2005 US) in Estonia in 2001 to that in 2004?
Provide a short and direct response. 0.81. What is the ratio of the GDP(constant 2005 US) in Liechtenstein in 2001 to that in 2004?
Your answer should be very brief. 1.03. What is the ratio of the GDP(constant 2005 US) of Channel Islands in 2001 to that in 2005?
Give a very brief answer. 1.06. What is the ratio of the GDP(constant 2005 US) of Estonia in 2001 to that in 2005?
Offer a terse response. 0.74. What is the ratio of the GDP(constant 2005 US) in Liechtenstein in 2001 to that in 2005?
Your response must be concise. 0.99. What is the ratio of the GDP(constant 2005 US) in Channel Islands in 2002 to that in 2003?
Keep it short and to the point. 1.04. What is the ratio of the GDP(constant 2005 US) of Estonia in 2002 to that in 2003?
Your response must be concise. 0.93. What is the ratio of the GDP(constant 2005 US) of Liechtenstein in 2002 to that in 2003?
Your answer should be compact. 1.03. What is the ratio of the GDP(constant 2005 US) in Channel Islands in 2002 to that in 2004?
Your answer should be compact. 1.05. What is the ratio of the GDP(constant 2005 US) in Estonia in 2002 to that in 2004?
Offer a very short reply. 0.87. What is the ratio of the GDP(constant 2005 US) of Liechtenstein in 2002 to that in 2004?
Provide a short and direct response. 1.01. What is the ratio of the GDP(constant 2005 US) in Channel Islands in 2002 to that in 2005?
Provide a succinct answer. 1.04. What is the ratio of the GDP(constant 2005 US) of Estonia in 2002 to that in 2005?
Give a very brief answer. 0.79. What is the ratio of the GDP(constant 2005 US) in Liechtenstein in 2002 to that in 2005?
Offer a very short reply. 0.97. What is the ratio of the GDP(constant 2005 US) in Channel Islands in 2003 to that in 2004?
Keep it short and to the point. 1.01. What is the ratio of the GDP(constant 2005 US) of Estonia in 2003 to that in 2004?
Provide a short and direct response. 0.94. What is the ratio of the GDP(constant 2005 US) in Liechtenstein in 2003 to that in 2004?
Give a very brief answer. 0.98. What is the ratio of the GDP(constant 2005 US) of Channel Islands in 2003 to that in 2005?
Ensure brevity in your answer.  1. What is the ratio of the GDP(constant 2005 US) in Estonia in 2003 to that in 2005?
Keep it short and to the point. 0.85. What is the ratio of the GDP(constant 2005 US) of Liechtenstein in 2003 to that in 2005?
Your answer should be compact. 0.94. What is the ratio of the GDP(constant 2005 US) of Estonia in 2004 to that in 2005?
Provide a succinct answer. 0.91. What is the ratio of the GDP(constant 2005 US) in Liechtenstein in 2004 to that in 2005?
Your response must be concise. 0.96. What is the difference between the highest and the second highest GDP(constant 2005 US) of Channel Islands?
Keep it short and to the point. 1381.48. What is the difference between the highest and the second highest GDP(constant 2005 US) in Estonia?
Make the answer very short. 939.97. What is the difference between the highest and the second highest GDP(constant 2005 US) in Liechtenstein?
Provide a short and direct response. 623. What is the difference between the highest and the lowest GDP(constant 2005 US) in Channel Islands?
Provide a succinct answer. 5444.28. What is the difference between the highest and the lowest GDP(constant 2005 US) in Estonia?
Provide a succinct answer. 3824.29. What is the difference between the highest and the lowest GDP(constant 2005 US) in Liechtenstein?
Ensure brevity in your answer.  1.03e+04. 